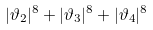Convert formula to latex. <formula><loc_0><loc_0><loc_500><loc_500>| \vartheta _ { 2 } | ^ { 8 } + | \vartheta _ { 3 } | ^ { 8 } + | \vartheta _ { 4 } | ^ { 8 }</formula> 